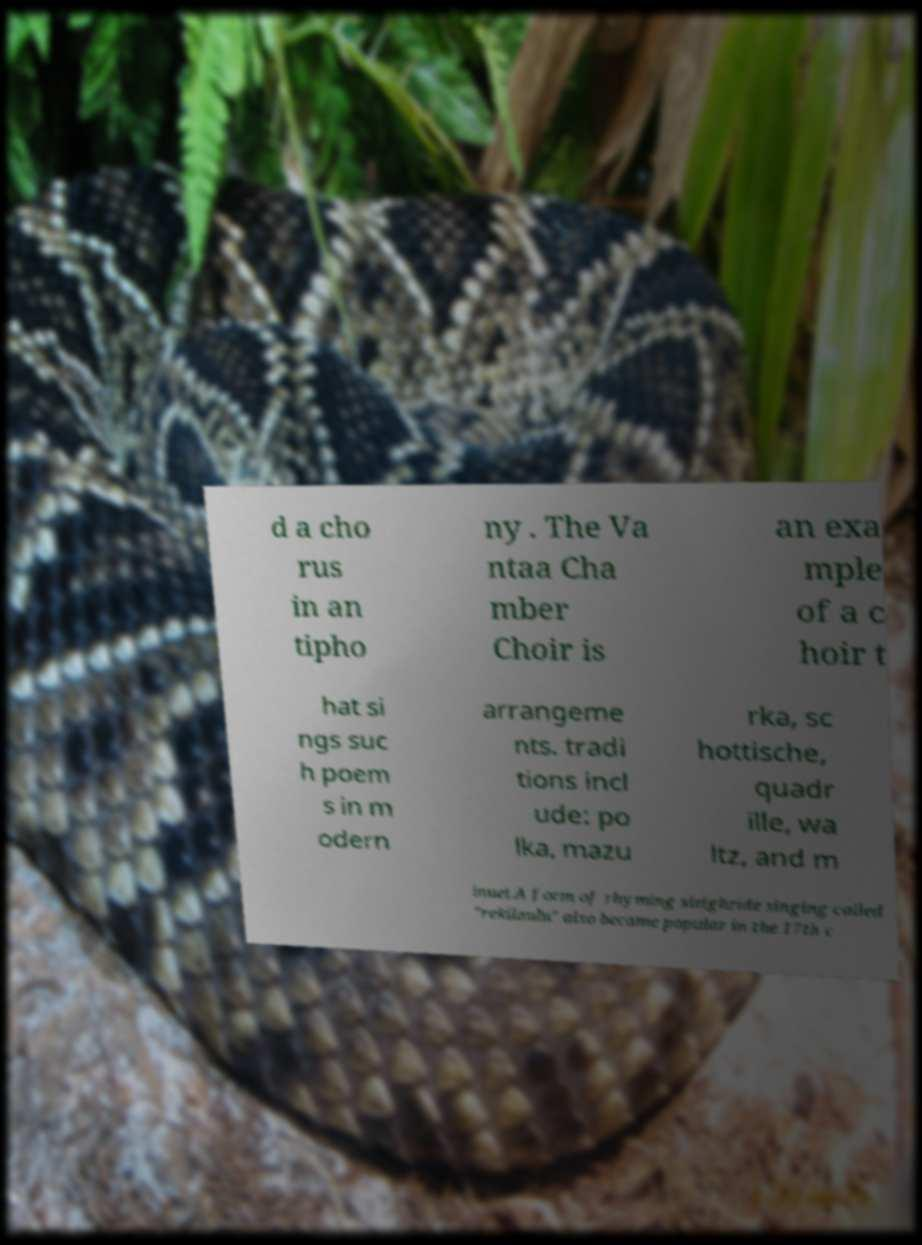Could you assist in decoding the text presented in this image and type it out clearly? d a cho rus in an tipho ny . The Va ntaa Cha mber Choir is an exa mple of a c hoir t hat si ngs suc h poem s in m odern arrangeme nts. tradi tions incl ude: po lka, mazu rka, sc hottische, quadr ille, wa ltz, and m inuet.A form of rhyming sleighride singing called "rekilaulu" also became popular in the 17th c 